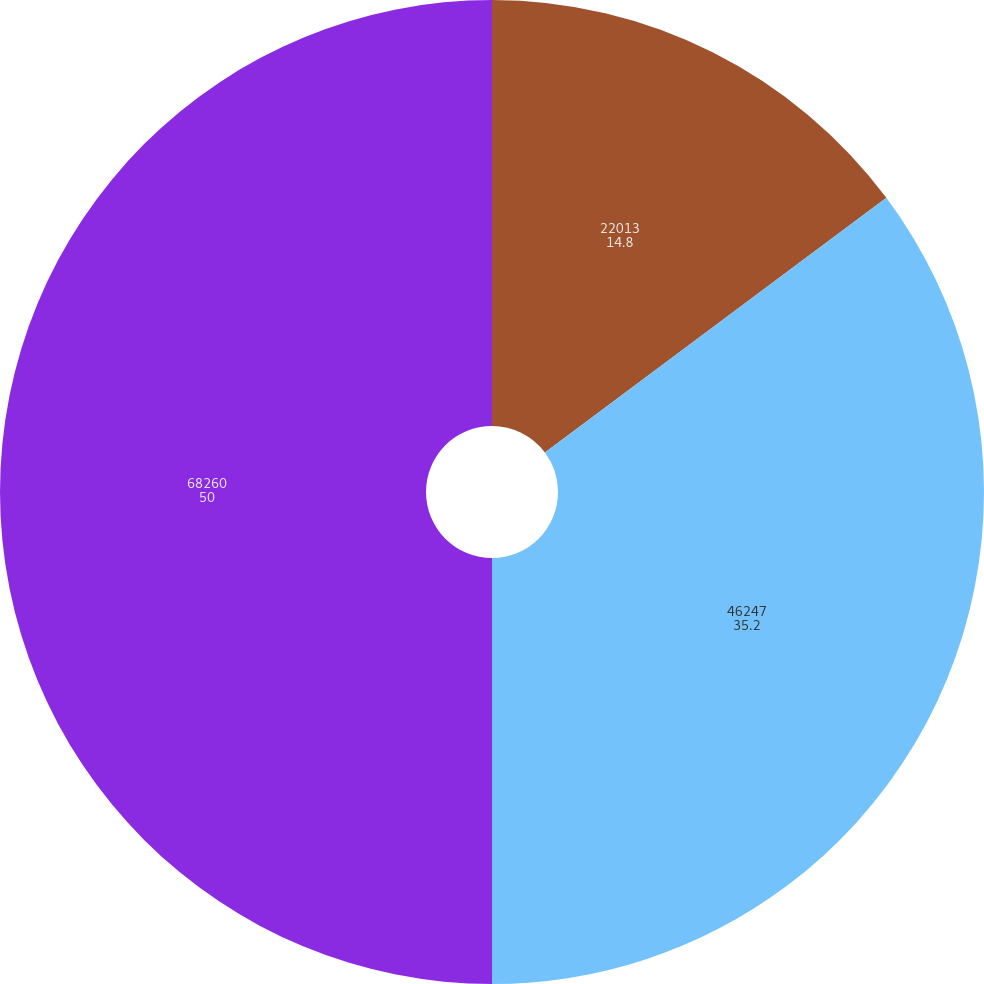Convert chart to OTSL. <chart><loc_0><loc_0><loc_500><loc_500><pie_chart><fcel>22013<fcel>46247<fcel>68260<nl><fcel>14.8%<fcel>35.2%<fcel>50.0%<nl></chart> 